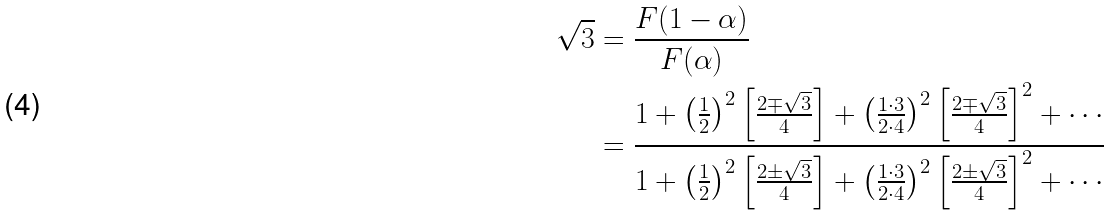Convert formula to latex. <formula><loc_0><loc_0><loc_500><loc_500>\sqrt { 3 } & = \frac { F ( 1 - \alpha ) } { F ( \alpha ) } \\ & = \frac { 1 + \left ( \frac { 1 } { 2 } \right ) ^ { 2 } \left [ \frac { 2 \mp \sqrt { 3 } } { 4 } \right ] + \left ( \frac { 1 \cdot 3 } { 2 \cdot 4 } \right ) ^ { 2 } \left [ \frac { 2 \mp \sqrt { 3 } } { 4 } \right ] ^ { 2 } + \cdots } { 1 + \left ( \frac { 1 } { 2 } \right ) ^ { 2 } \left [ \frac { 2 \pm \sqrt { 3 } } { 4 } \right ] + \left ( \frac { 1 \cdot 3 } { 2 \cdot 4 } \right ) ^ { 2 } \left [ \frac { 2 \pm \sqrt { 3 } } { 4 } \right ] ^ { 2 } + \cdots }</formula> 